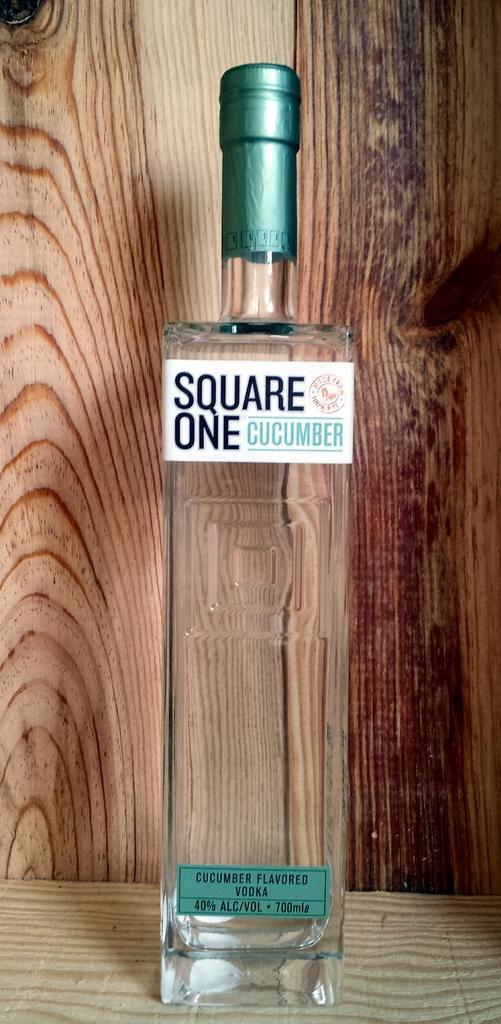What is in the image that is used for holding liquids? There is a bottle in the image that is used for holding liquids. What type of bottle is it, and what is written on it? The bottle is labelled as "Square One Cucumber." What color is the cap of the bottle? The bottle has a green cap. What other object can be seen in the image besides the bottle? There is a wooden plank in the image. How many cows are visible in the image? There are no cows present in the image. What type of channel is the bottle being used in the image? The image does not depict a channel, and the bottle is not being used in one. 